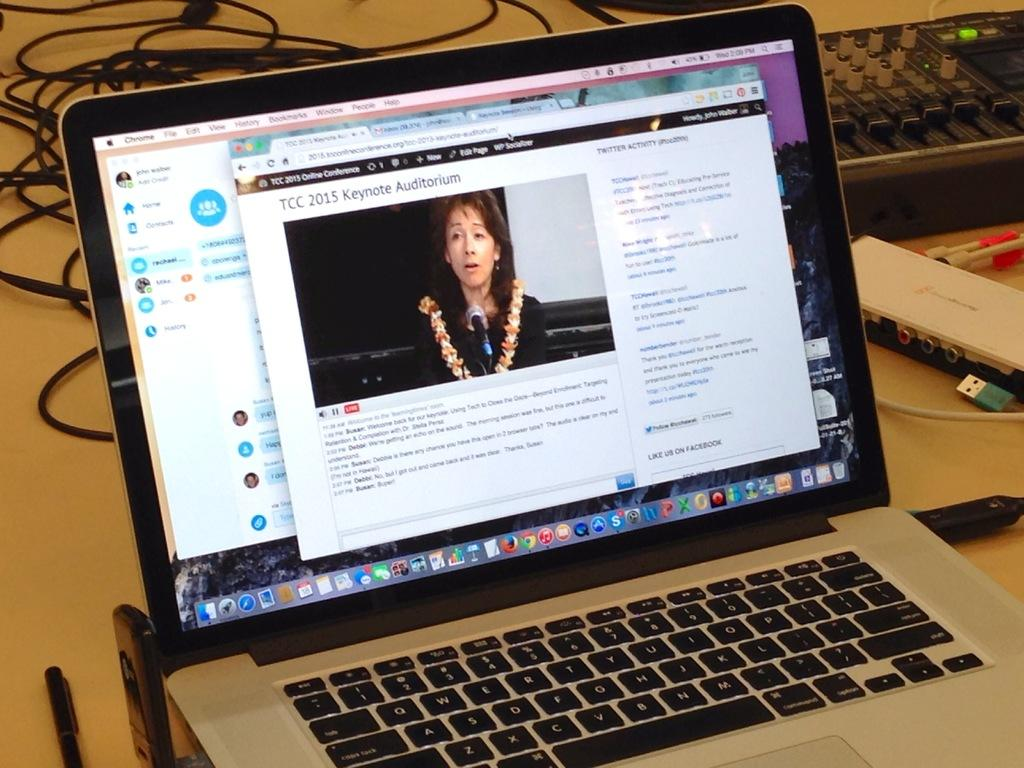<image>
Give a short and clear explanation of the subsequent image. A screen displays a TCC 2015 keynote speaker. 